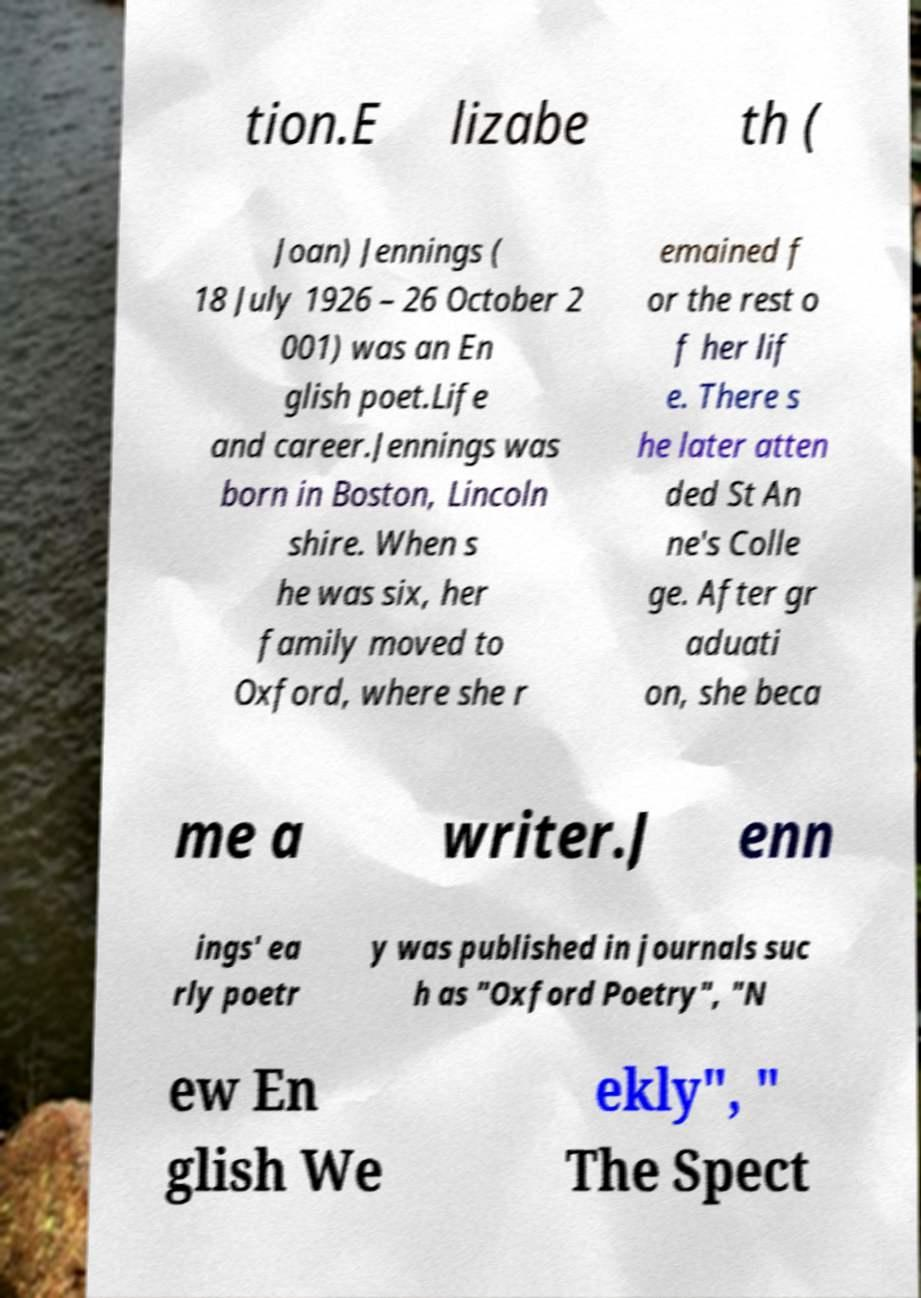Can you accurately transcribe the text from the provided image for me? tion.E lizabe th ( Joan) Jennings ( 18 July 1926 – 26 October 2 001) was an En glish poet.Life and career.Jennings was born in Boston, Lincoln shire. When s he was six, her family moved to Oxford, where she r emained f or the rest o f her lif e. There s he later atten ded St An ne's Colle ge. After gr aduati on, she beca me a writer.J enn ings' ea rly poetr y was published in journals suc h as "Oxford Poetry", "N ew En glish We ekly", " The Spect 